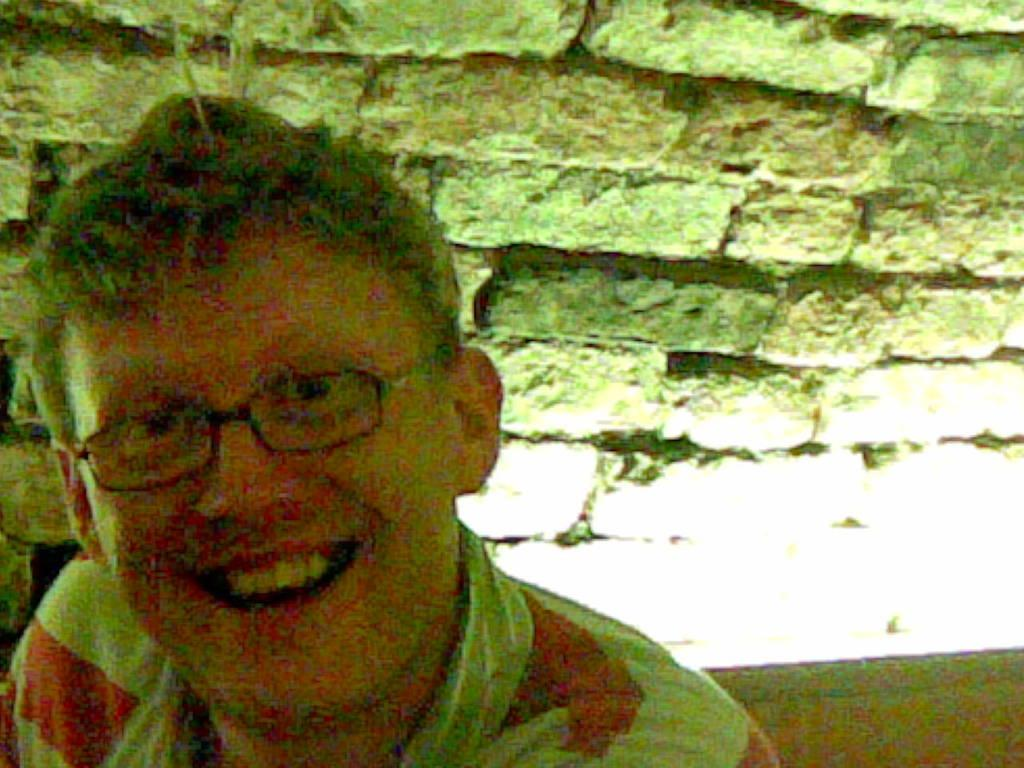What is the main subject in the foreground of the image? There is a person in the foreground of the image. What is the person doing in the image? The person is smiling. What is the person wearing in the image? The person is wearing a white and red striped t-shirt. What can be seen in the background of the image? There is a brick wall in the background of the image. Can you see a frog sitting on the person's shoulder in the image? No, there is no frog present in the image. What type of rake is the person using to clean the brick wall in the image? There is no rake or cleaning activity depicted in the image; the person is simply smiling and wearing a striped t-shirt. 